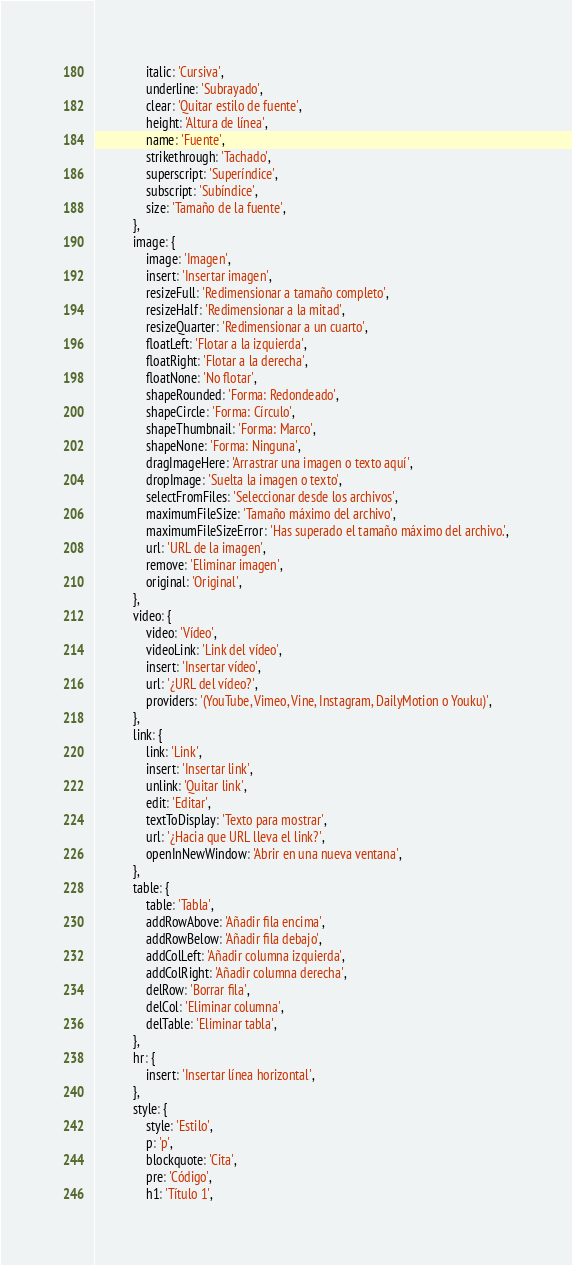<code> <loc_0><loc_0><loc_500><loc_500><_JavaScript_>                italic: 'Cursiva',
                underline: 'Subrayado',
                clear: 'Quitar estilo de fuente',
                height: 'Altura de línea',
                name: 'Fuente',
                strikethrough: 'Tachado',
                superscript: 'Superíndice',
                subscript: 'Subíndice',
                size: 'Tamaño de la fuente',
            },
            image: {
                image: 'Imagen',
                insert: 'Insertar imagen',
                resizeFull: 'Redimensionar a tamaño completo',
                resizeHalf: 'Redimensionar a la mitad',
                resizeQuarter: 'Redimensionar a un cuarto',
                floatLeft: 'Flotar a la izquierda',
                floatRight: 'Flotar a la derecha',
                floatNone: 'No flotar',
                shapeRounded: 'Forma: Redondeado',
                shapeCircle: 'Forma: Círculo',
                shapeThumbnail: 'Forma: Marco',
                shapeNone: 'Forma: Ninguna',
                dragImageHere: 'Arrastrar una imagen o texto aquí',
                dropImage: 'Suelta la imagen o texto',
                selectFromFiles: 'Seleccionar desde los archivos',
                maximumFileSize: 'Tamaño máximo del archivo',
                maximumFileSizeError: 'Has superado el tamaño máximo del archivo.',
                url: 'URL de la imagen',
                remove: 'Eliminar imagen',
                original: 'Original',
            },
            video: {
                video: 'Vídeo',
                videoLink: 'Link del vídeo',
                insert: 'Insertar vídeo',
                url: '¿URL del vídeo?',
                providers: '(YouTube, Vimeo, Vine, Instagram, DailyMotion o Youku)',
            },
            link: {
                link: 'Link',
                insert: 'Insertar link',
                unlink: 'Quitar link',
                edit: 'Editar',
                textToDisplay: 'Texto para mostrar',
                url: '¿Hacia que URL lleva el link?',
                openInNewWindow: 'Abrir en una nueva ventana',
            },
            table: {
                table: 'Tabla',
                addRowAbove: 'Añadir fila encima',
                addRowBelow: 'Añadir fila debajo',
                addColLeft: 'Añadir columna izquierda',
                addColRight: 'Añadir columna derecha',
                delRow: 'Borrar fila',
                delCol: 'Eliminar columna',
                delTable: 'Eliminar tabla',
            },
            hr: {
                insert: 'Insertar línea horizontal',
            },
            style: {
                style: 'Estilo',
                p: 'p',
                blockquote: 'Cita',
                pre: 'Código',
                h1: 'Título 1',</code> 